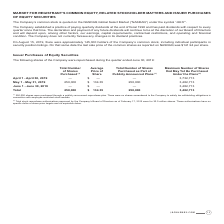From Jack Henry Associates's financial document, What are the three date periods shown in the table? The document contains multiple relevant values: April 1 - April 30, 2019, May 1 - May 31, 2019, June 1 - June 30, 2019. From the document: "May 1 - May 31, 2019 250,000 $ 134.35 250,000 3,482,713 April 1 - April 30, 2019 — $ — — 3,732,713 June 1 - June 30, 2019 — $ — — 3,482,713..." Also, What are the maximum number of shares that may yet be purchased under the plans as at April 1 - April 30, 2019 and May 1 - May 31, 2019 respectively? The document shows two values: 3,732,713 and 3,482,713. From the document: "April 1 - April 30, 2019 — $ — — 3,732,713 May 1 - May 31, 2019 250,000 $ 134.35 250,000 3,482,713..." Also, What is the total number of shares purchased? According to the financial document, 250,000. The relevant text states: "May 1 - May 31, 2019 250,000 $ 134.35 250,000 3,482,713..." Additionally, Between April 1 - April 30, 2019 and May 1 - May 31, 2019, which period had a greater amount of maximum number of shares that may yet be purchased under the plans? April 1 - April 30, 2019. The document states: "April 1 - April 30, 2019 — $ — — 3,732,713..." Also, can you calculate: What was the cost of the shares purchased from May 1 - May 31, 2019? Based on the calculation: 250,000*$134.35, the result is 33587500. This is based on the information: "May 1 - May 31, 2019 250,000 $ 134.35 250,000 3,482,713 May 1 - May 31, 2019 250,000 $ 134.35 250,000 3,482,713..." The key data points involved are: 134.35, 250,000. Also, can you calculate: What percentage of maximum shares that may yet be purchased under the plans as at April 1 - April 30, 2019 is the maximum number of shares that may be purchased as at May 1 - May 31,2019? Based on the calculation: 3,482,713/3,732,713, the result is 93.3 (percentage). This is based on the information: "April 1 - April 30, 2019 — $ — — 3,732,713 May 1 - May 31, 2019 250,000 $ 134.35 250,000 3,482,713..." The key data points involved are: 3,482,713, 3,732,713. 